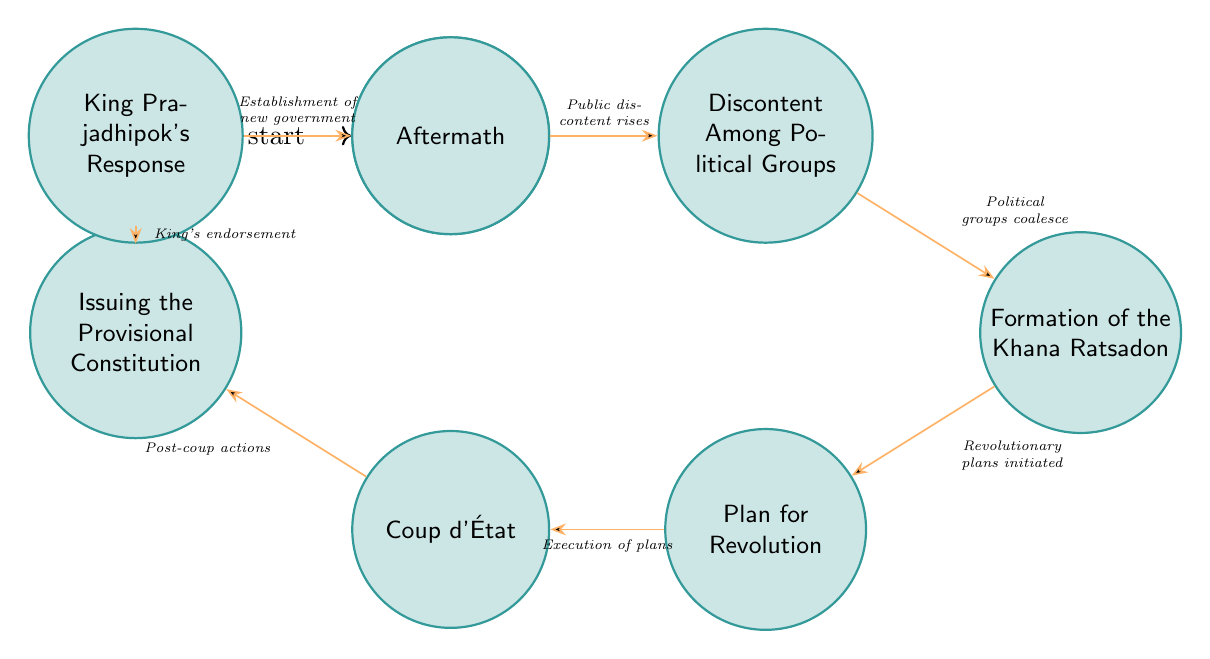What event precedes the "Formation of the Khana Ratsadon"? The diagram shows a transition from "Discontent Among Political Groups" to "Formation of the Khana Ratsadon." Therefore, the event that leads to the formation of this group is the rising discontent among different political factions.
Answer: Discontent Among Political Groups What action occurs after "Plan for Revolution"? The flow in the diagram indicates that after the "Plan for Revolution" stage, the next event is the "Coup d'État," which signifies the execution of the planned actions.
Answer: Coup d'État How many states are in the diagram? By counting each node in the diagram, there are a total of eight states listed, including the starting point and the aftermath.
Answer: 8 What is the initial state in the diagram? The diagram's starting node is labeled "Start," which is indicated as the initial state where the Siamese Revolution begins.
Answer: Start What is the final state after the King's response? The state that follows "King Prajadhipok's Response" in the diagram is "Aftermath," which reflects the consequences of the King's agreement to the changes.
Answer: Aftermath What signifies the transition from "Coup d'État" to the next state? The transition from "Coup d'État" to "Issuing the Provisional Constitution" is marked by post-coup actions taken by the People's Party to formalize the revolution's outcomes.
Answer: Post-coup actions Which state represents the successful execution of the plans? According to the diagram, the successful execution of the plans is represented by the state "Coup d'État," where the coup is carried out.
Answer: Coup d'État How does the King respond to the demands of the People's Party? The diagram shows that the King's response leads to the next state, wherein he agrees to the demands put forth by the People's Party, marking a significant political change.
Answer: King's endorsement What is the relationship between "Formation of the Khana Ratsadon" and "Discontent Among Political Groups"? The diagram illustrates that the "Formation of the Khana Ratsadon" follows after the "Discontent Among Political Groups," indicating that the unrest prompted a political organization to form.
Answer: Political groups coalesce 